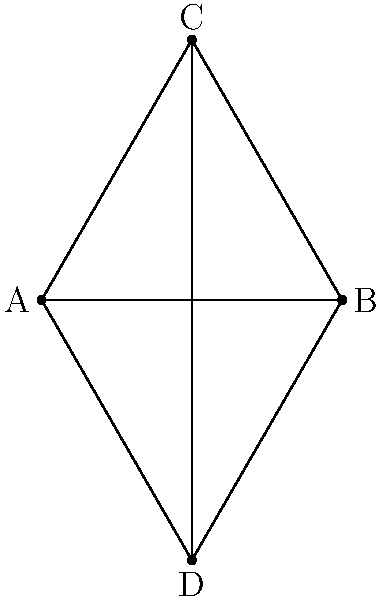Your college student friend has shown you this network diagram. Can you identify the network topology represented in this simple diagram? To identify the network topology, let's analyze the diagram step-by-step:

1. Count the nodes: There are 4 nodes (A, B, C, and D).
2. Observe the connections: Each node is connected to every other node.
3. Check for central nodes: There is no central node; all nodes have equal importance.
4. Compare with known topologies:
   - It's not a bus topology, as there's no central line.
   - It's not a star topology, as there's no central hub.
   - It's not a ring topology, as it doesn't form a closed loop.
   - It matches the characteristics of a mesh topology, where each node is connected to every other node.

5. Verify full connectivity: Each node has 3 connections (to the other 3 nodes), confirming a full mesh topology.

The diagram represents a full mesh topology, where every node is directly connected to every other node in the network.
Answer: Mesh topology 